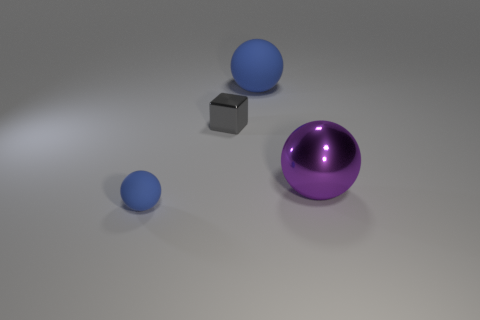Add 2 big purple metal spheres. How many objects exist? 6 Subtract all balls. How many objects are left? 1 Add 3 tiny objects. How many tiny objects exist? 5 Subtract 0 cyan cubes. How many objects are left? 4 Subtract all large things. Subtract all big gray rubber cubes. How many objects are left? 2 Add 4 big metal objects. How many big metal objects are left? 5 